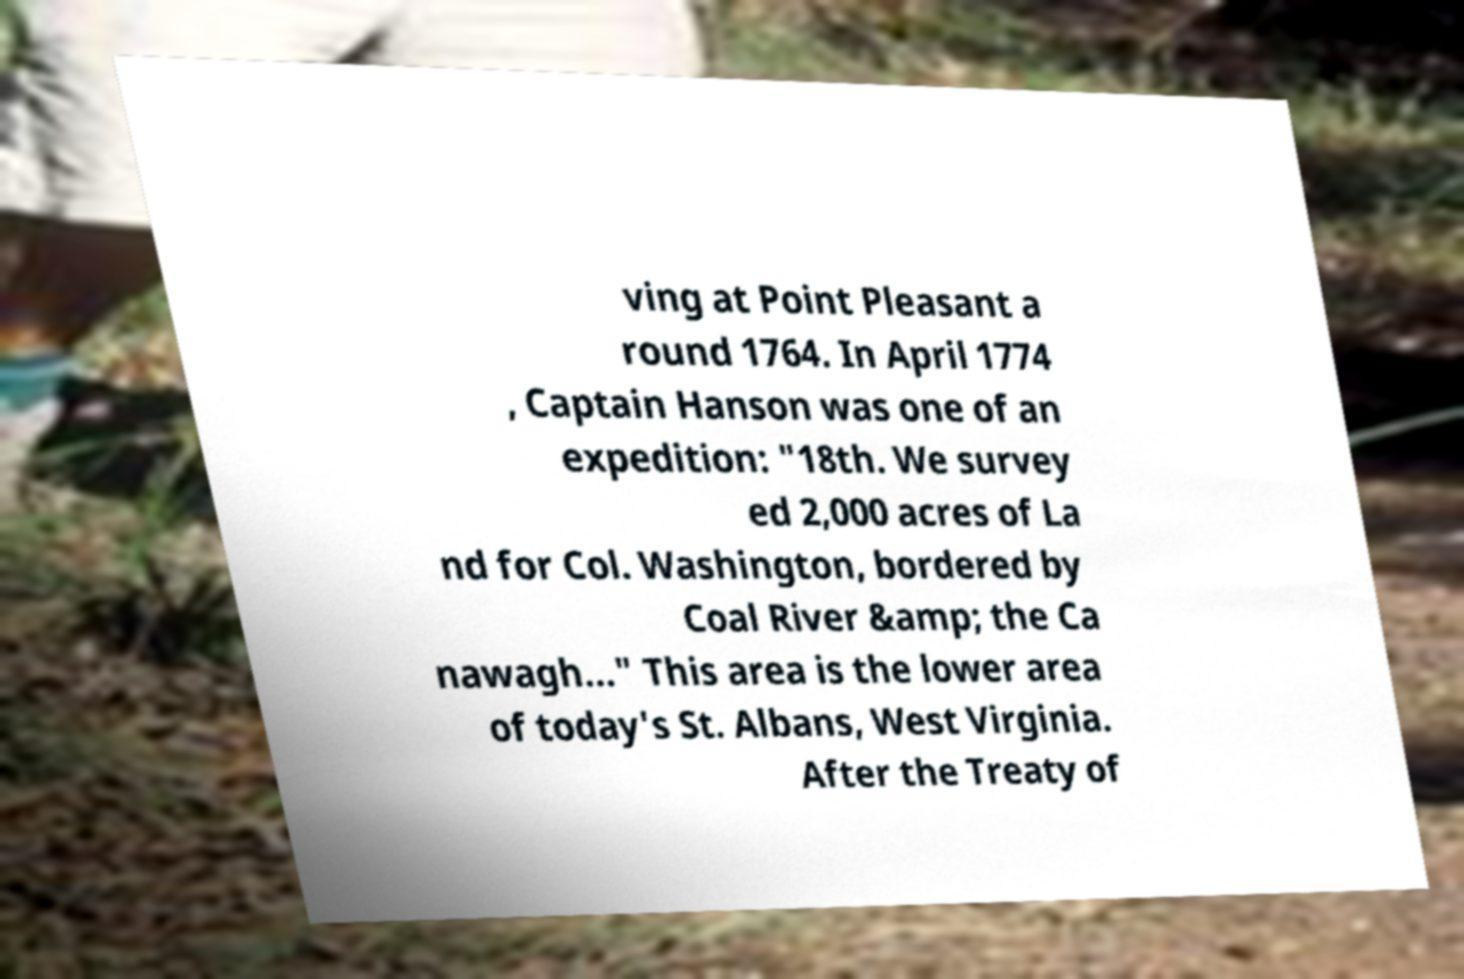Could you extract and type out the text from this image? ving at Point Pleasant a round 1764. In April 1774 , Captain Hanson was one of an expedition: "18th. We survey ed 2,000 acres of La nd for Col. Washington, bordered by Coal River &amp; the Ca nawagh..." This area is the lower area of today's St. Albans, West Virginia. After the Treaty of 